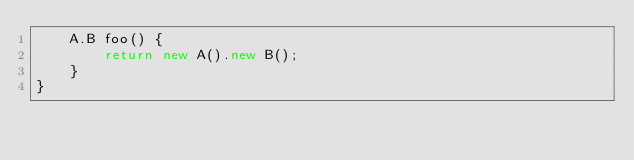<code> <loc_0><loc_0><loc_500><loc_500><_Java_>    A.B foo() {
        return new A().new B();
    }
}</code> 